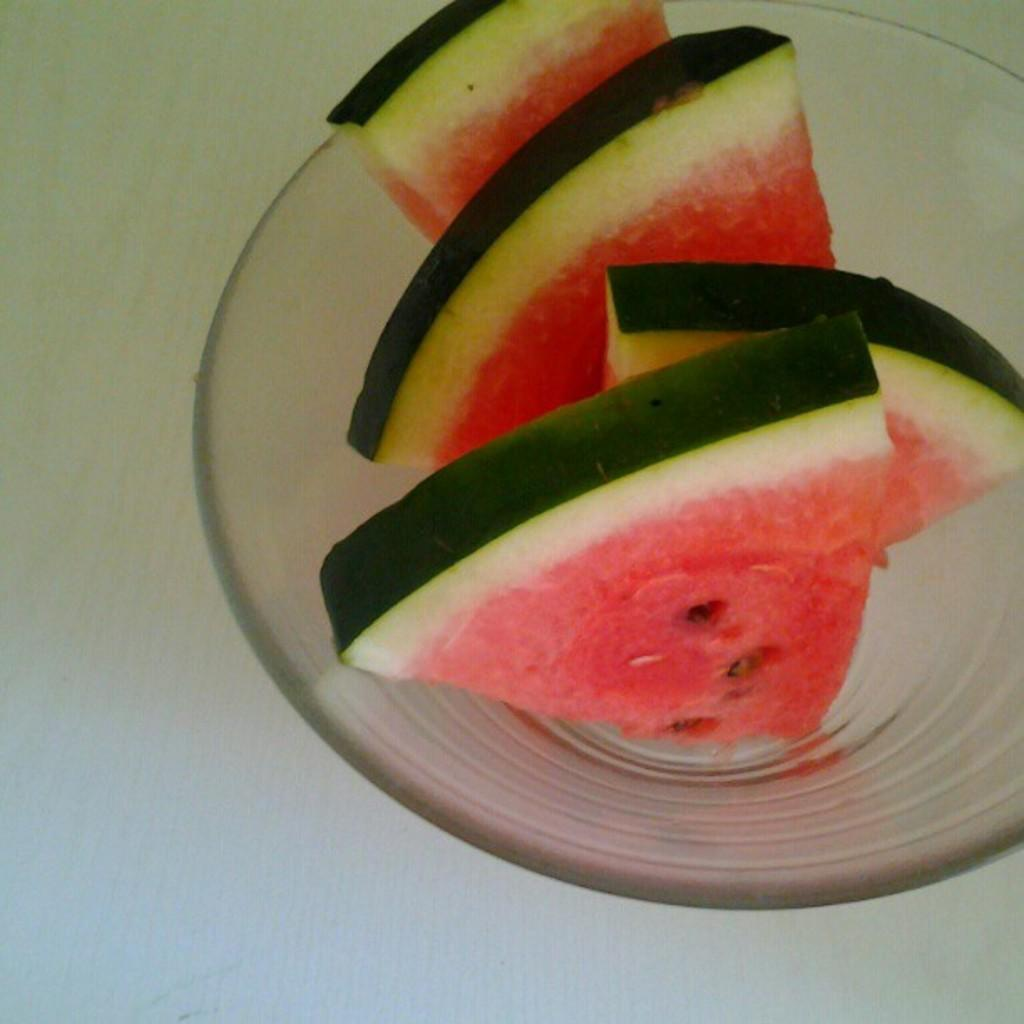What is in the image that can hold food or liquid? There is a bowl in the image. Where is the bowl located in the image? The bowl is on a surface. What type of food can be seen in the bowl? There are watermelon pieces in the bowl. Can you see any jellyfish swimming in the bowl in the image? No, there are no jellyfish present in the image. The bowl contains watermelon pieces. 